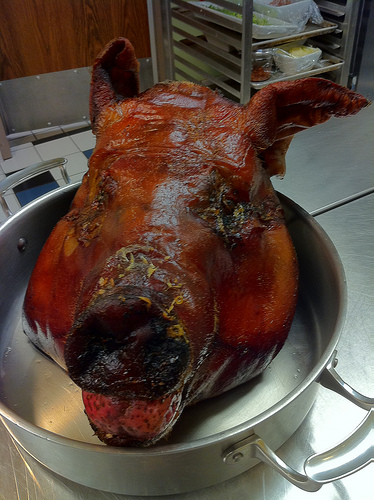<image>
Is the head above the pot? No. The head is not positioned above the pot. The vertical arrangement shows a different relationship. 